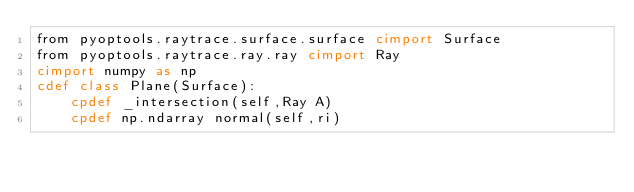Convert code to text. <code><loc_0><loc_0><loc_500><loc_500><_Cython_>from pyoptools.raytrace.surface.surface cimport Surface
from pyoptools.raytrace.ray.ray cimport Ray
cimport numpy as np
cdef class Plane(Surface):
    cpdef _intersection(self,Ray A)
    cpdef np.ndarray normal(self,ri)
</code> 